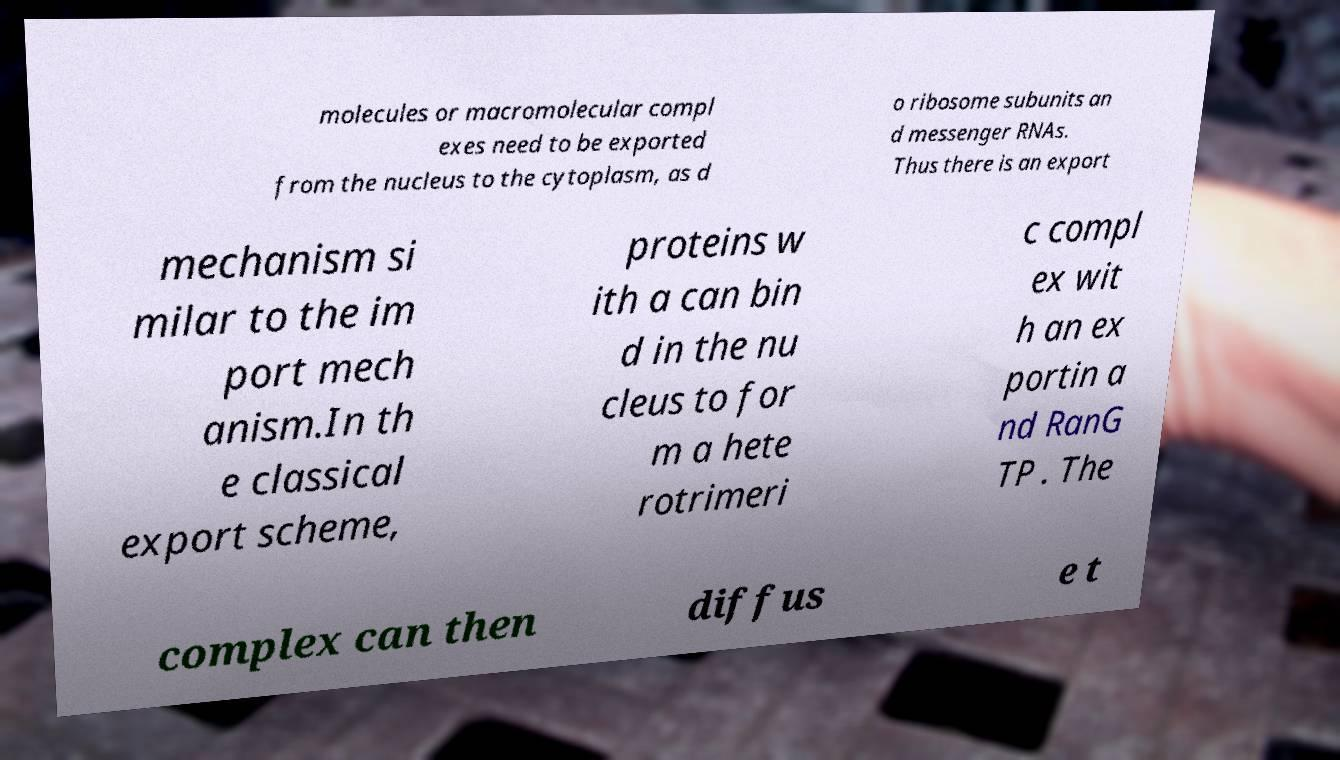What messages or text are displayed in this image? I need them in a readable, typed format. molecules or macromolecular compl exes need to be exported from the nucleus to the cytoplasm, as d o ribosome subunits an d messenger RNAs. Thus there is an export mechanism si milar to the im port mech anism.In th e classical export scheme, proteins w ith a can bin d in the nu cleus to for m a hete rotrimeri c compl ex wit h an ex portin a nd RanG TP . The complex can then diffus e t 